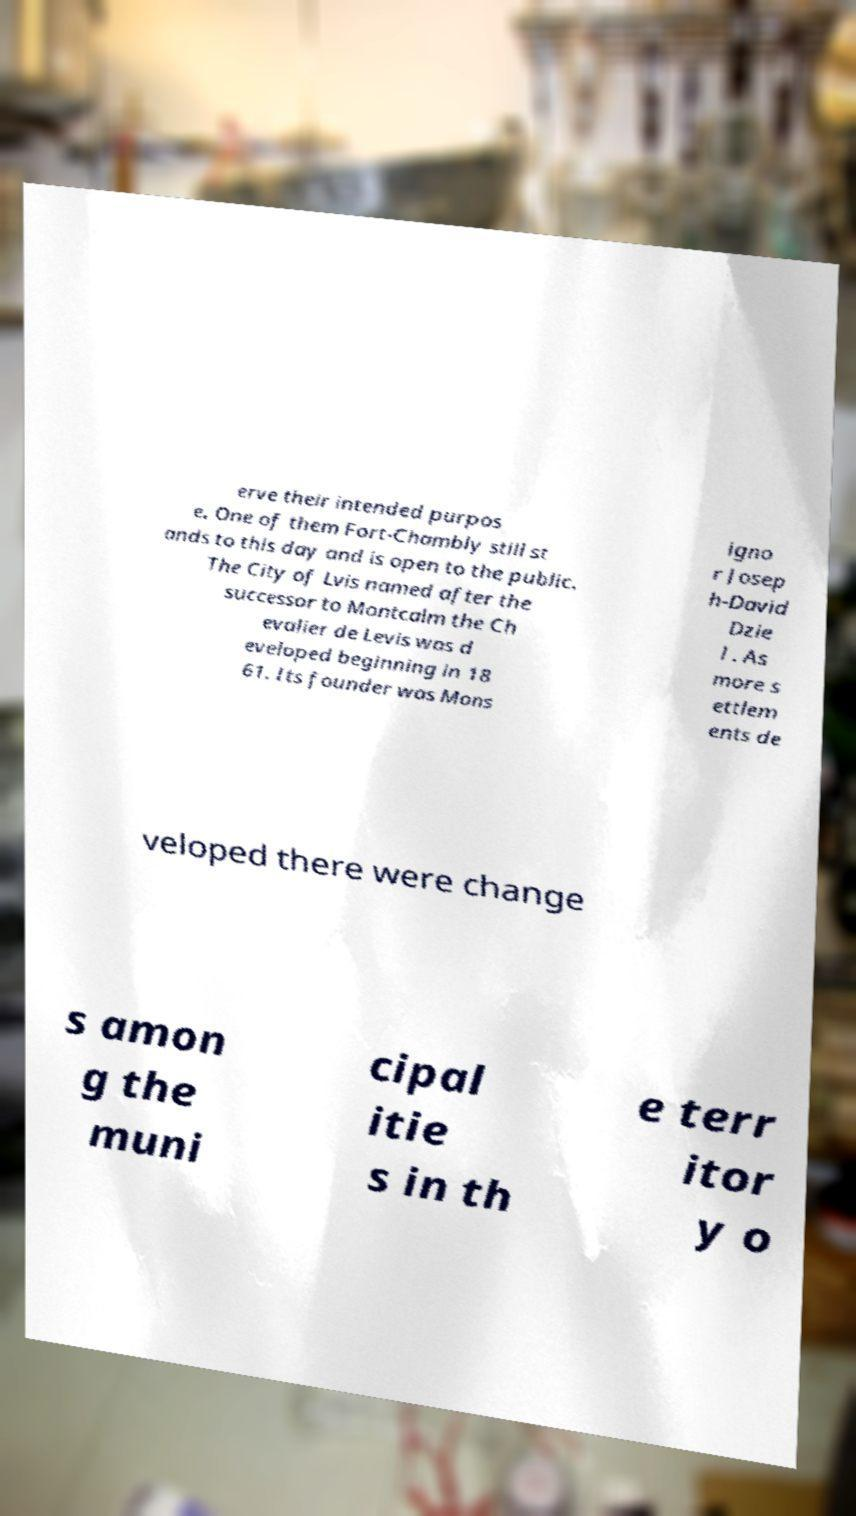For documentation purposes, I need the text within this image transcribed. Could you provide that? erve their intended purpos e. One of them Fort-Chambly still st ands to this day and is open to the public. The City of Lvis named after the successor to Montcalm the Ch evalier de Levis was d eveloped beginning in 18 61. Its founder was Mons igno r Josep h-David Dzie l . As more s ettlem ents de veloped there were change s amon g the muni cipal itie s in th e terr itor y o 